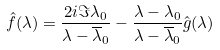<formula> <loc_0><loc_0><loc_500><loc_500>\hat { f } ( \lambda ) = \frac { 2 i \Im \lambda _ { 0 } } { \lambda - \overline { \lambda } _ { 0 } } - \frac { \lambda - \lambda _ { 0 } } { \lambda - \overline { \lambda } _ { 0 } } \hat { g } ( \lambda )</formula> 